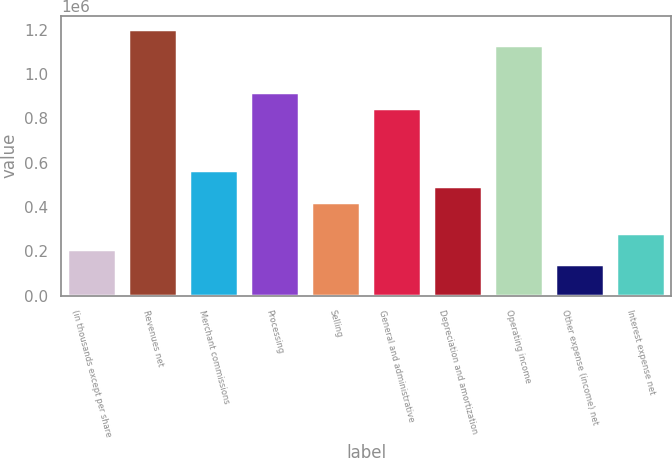Convert chart to OTSL. <chart><loc_0><loc_0><loc_500><loc_500><bar_chart><fcel>(in thousands except per share<fcel>Revenues net<fcel>Merchant commissions<fcel>Processing<fcel>Selling<fcel>General and administrative<fcel>Depreciation and amortization<fcel>Operating income<fcel>Other expense (income) net<fcel>Interest expense net<nl><fcel>212262<fcel>1.20281e+06<fcel>566028<fcel>919793<fcel>424521<fcel>849040<fcel>495275<fcel>1.13205e+06<fcel>141509<fcel>283015<nl></chart> 